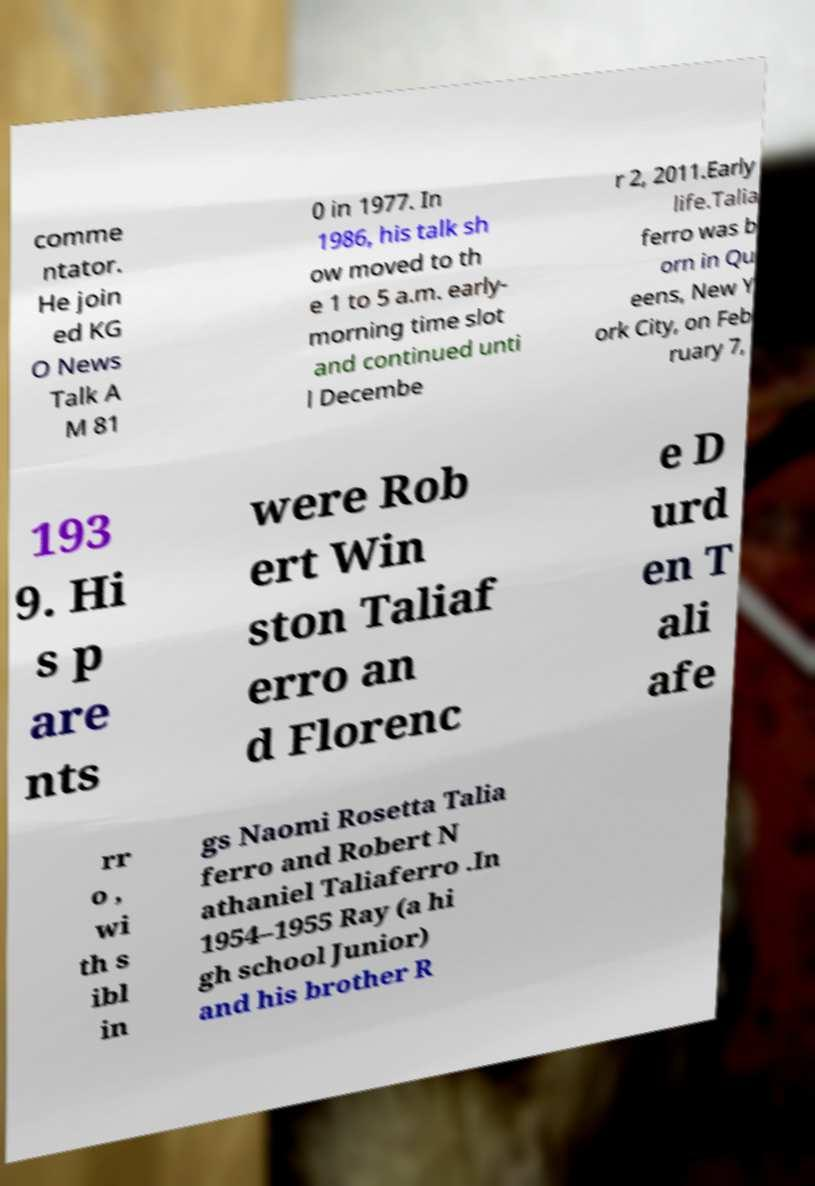I need the written content from this picture converted into text. Can you do that? comme ntator. He join ed KG O News Talk A M 81 0 in 1977. In 1986, his talk sh ow moved to th e 1 to 5 a.m. early- morning time slot and continued unti l Decembe r 2, 2011.Early life.Talia ferro was b orn in Qu eens, New Y ork City, on Feb ruary 7, 193 9. Hi s p are nts were Rob ert Win ston Taliaf erro an d Florenc e D urd en T ali afe rr o , wi th s ibl in gs Naomi Rosetta Talia ferro and Robert N athaniel Taliaferro .In 1954–1955 Ray (a hi gh school Junior) and his brother R 